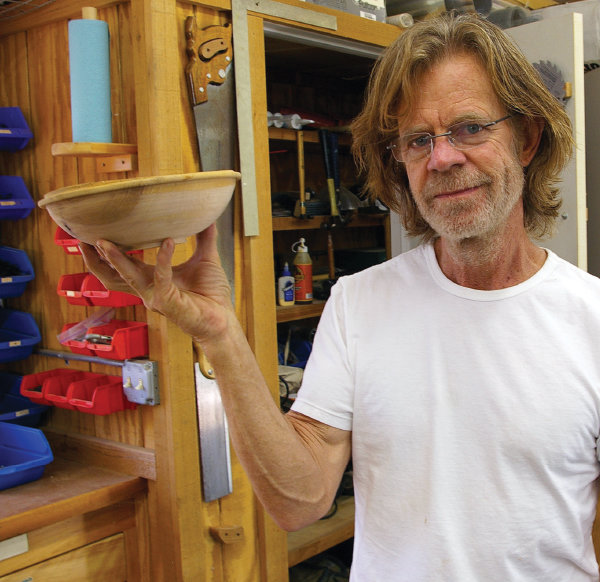Could you describe the tools visible in the background and their possible uses in woodworking? In the background, several woodworking tools can be seen, including clamps, chisels, and saws. Clamps are used to hold wood in place while gluing or cutting. Chisels are used for carving and shaping the wood, essential for creating intricate designs or smoothing surfaces. Saws, visible hanging, are employed for cutting the wood into desired shapes and sizes, suitable for different parts of a project like the bowl being held. 